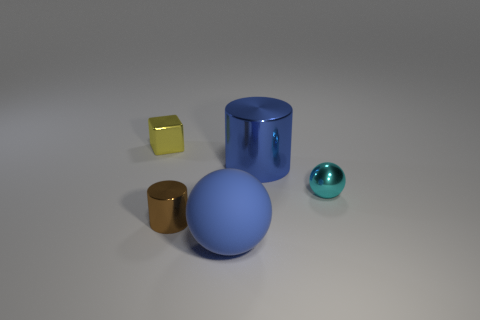How would you describe the lighting in this scene? The lighting in the scene is soft and diffused, casting gentle shadows and highlighting the geometry of the objects without causing strong glare. 